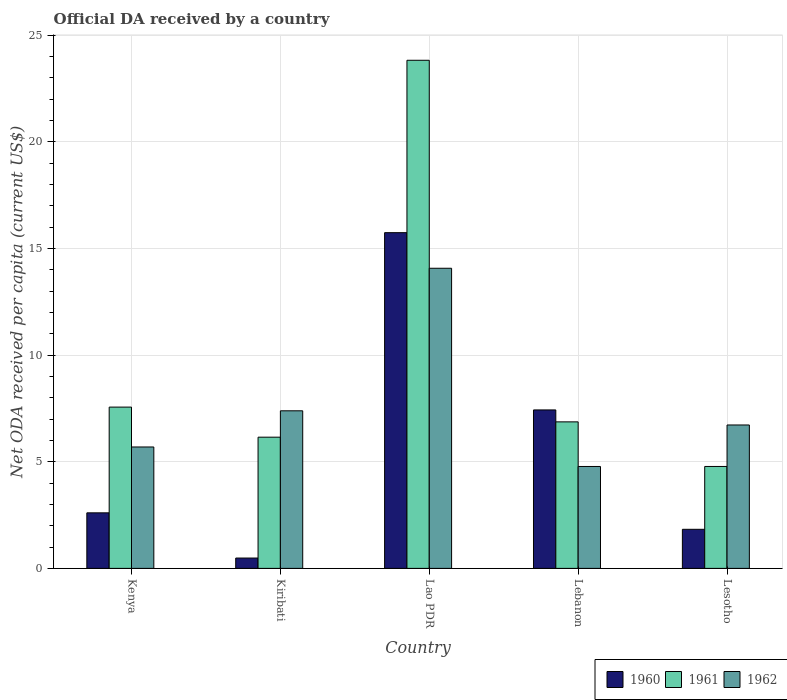How many different coloured bars are there?
Ensure brevity in your answer.  3. How many groups of bars are there?
Give a very brief answer. 5. Are the number of bars per tick equal to the number of legend labels?
Make the answer very short. Yes. Are the number of bars on each tick of the X-axis equal?
Your answer should be very brief. Yes. How many bars are there on the 5th tick from the left?
Offer a very short reply. 3. What is the label of the 1st group of bars from the left?
Offer a terse response. Kenya. In how many cases, is the number of bars for a given country not equal to the number of legend labels?
Offer a very short reply. 0. What is the ODA received in in 1962 in Lebanon?
Provide a short and direct response. 4.78. Across all countries, what is the maximum ODA received in in 1960?
Your answer should be very brief. 15.74. Across all countries, what is the minimum ODA received in in 1961?
Your answer should be very brief. 4.78. In which country was the ODA received in in 1961 maximum?
Keep it short and to the point. Lao PDR. In which country was the ODA received in in 1961 minimum?
Provide a short and direct response. Lesotho. What is the total ODA received in in 1961 in the graph?
Offer a very short reply. 49.19. What is the difference between the ODA received in in 1960 in Lao PDR and that in Lesotho?
Provide a short and direct response. 13.91. What is the difference between the ODA received in in 1961 in Lao PDR and the ODA received in in 1962 in Lesotho?
Your response must be concise. 17.1. What is the average ODA received in in 1962 per country?
Provide a short and direct response. 7.73. What is the difference between the ODA received in of/in 1960 and ODA received in of/in 1962 in Kiribati?
Offer a very short reply. -6.9. In how many countries, is the ODA received in in 1960 greater than 18 US$?
Offer a terse response. 0. What is the ratio of the ODA received in in 1961 in Lao PDR to that in Lesotho?
Keep it short and to the point. 4.98. Is the ODA received in in 1960 in Kiribati less than that in Lao PDR?
Provide a succinct answer. Yes. Is the difference between the ODA received in in 1960 in Kenya and Lao PDR greater than the difference between the ODA received in in 1962 in Kenya and Lao PDR?
Provide a short and direct response. No. What is the difference between the highest and the second highest ODA received in in 1960?
Give a very brief answer. -4.83. What is the difference between the highest and the lowest ODA received in in 1960?
Offer a very short reply. 15.26. In how many countries, is the ODA received in in 1960 greater than the average ODA received in in 1960 taken over all countries?
Provide a succinct answer. 2. What does the 2nd bar from the right in Lao PDR represents?
Your response must be concise. 1961. Is it the case that in every country, the sum of the ODA received in in 1961 and ODA received in in 1960 is greater than the ODA received in in 1962?
Provide a succinct answer. No. Are all the bars in the graph horizontal?
Offer a very short reply. No. How many countries are there in the graph?
Provide a short and direct response. 5. Are the values on the major ticks of Y-axis written in scientific E-notation?
Keep it short and to the point. No. Does the graph contain any zero values?
Ensure brevity in your answer.  No. Where does the legend appear in the graph?
Provide a succinct answer. Bottom right. How are the legend labels stacked?
Provide a short and direct response. Horizontal. What is the title of the graph?
Keep it short and to the point. Official DA received by a country. What is the label or title of the X-axis?
Ensure brevity in your answer.  Country. What is the label or title of the Y-axis?
Ensure brevity in your answer.  Net ODA received per capita (current US$). What is the Net ODA received per capita (current US$) of 1960 in Kenya?
Provide a short and direct response. 2.6. What is the Net ODA received per capita (current US$) in 1961 in Kenya?
Keep it short and to the point. 7.56. What is the Net ODA received per capita (current US$) in 1962 in Kenya?
Provide a short and direct response. 5.69. What is the Net ODA received per capita (current US$) in 1960 in Kiribati?
Keep it short and to the point. 0.49. What is the Net ODA received per capita (current US$) in 1961 in Kiribati?
Offer a terse response. 6.15. What is the Net ODA received per capita (current US$) in 1962 in Kiribati?
Provide a short and direct response. 7.39. What is the Net ODA received per capita (current US$) of 1960 in Lao PDR?
Your answer should be compact. 15.74. What is the Net ODA received per capita (current US$) in 1961 in Lao PDR?
Your response must be concise. 23.82. What is the Net ODA received per capita (current US$) in 1962 in Lao PDR?
Your response must be concise. 14.07. What is the Net ODA received per capita (current US$) of 1960 in Lebanon?
Offer a terse response. 7.43. What is the Net ODA received per capita (current US$) in 1961 in Lebanon?
Keep it short and to the point. 6.87. What is the Net ODA received per capita (current US$) in 1962 in Lebanon?
Offer a very short reply. 4.78. What is the Net ODA received per capita (current US$) in 1960 in Lesotho?
Provide a succinct answer. 1.83. What is the Net ODA received per capita (current US$) in 1961 in Lesotho?
Offer a terse response. 4.78. What is the Net ODA received per capita (current US$) of 1962 in Lesotho?
Provide a short and direct response. 6.72. Across all countries, what is the maximum Net ODA received per capita (current US$) in 1960?
Provide a succinct answer. 15.74. Across all countries, what is the maximum Net ODA received per capita (current US$) in 1961?
Your answer should be compact. 23.82. Across all countries, what is the maximum Net ODA received per capita (current US$) of 1962?
Your answer should be compact. 14.07. Across all countries, what is the minimum Net ODA received per capita (current US$) in 1960?
Give a very brief answer. 0.49. Across all countries, what is the minimum Net ODA received per capita (current US$) in 1961?
Keep it short and to the point. 4.78. Across all countries, what is the minimum Net ODA received per capita (current US$) of 1962?
Your answer should be compact. 4.78. What is the total Net ODA received per capita (current US$) in 1960 in the graph?
Offer a very short reply. 28.09. What is the total Net ODA received per capita (current US$) of 1961 in the graph?
Provide a short and direct response. 49.19. What is the total Net ODA received per capita (current US$) in 1962 in the graph?
Provide a succinct answer. 38.66. What is the difference between the Net ODA received per capita (current US$) of 1960 in Kenya and that in Kiribati?
Provide a short and direct response. 2.12. What is the difference between the Net ODA received per capita (current US$) of 1961 in Kenya and that in Kiribati?
Provide a succinct answer. 1.41. What is the difference between the Net ODA received per capita (current US$) in 1962 in Kenya and that in Kiribati?
Ensure brevity in your answer.  -1.7. What is the difference between the Net ODA received per capita (current US$) of 1960 in Kenya and that in Lao PDR?
Offer a terse response. -13.14. What is the difference between the Net ODA received per capita (current US$) in 1961 in Kenya and that in Lao PDR?
Your answer should be compact. -16.26. What is the difference between the Net ODA received per capita (current US$) of 1962 in Kenya and that in Lao PDR?
Keep it short and to the point. -8.38. What is the difference between the Net ODA received per capita (current US$) in 1960 in Kenya and that in Lebanon?
Your answer should be compact. -4.83. What is the difference between the Net ODA received per capita (current US$) of 1961 in Kenya and that in Lebanon?
Your response must be concise. 0.69. What is the difference between the Net ODA received per capita (current US$) of 1962 in Kenya and that in Lebanon?
Make the answer very short. 0.91. What is the difference between the Net ODA received per capita (current US$) in 1960 in Kenya and that in Lesotho?
Ensure brevity in your answer.  0.77. What is the difference between the Net ODA received per capita (current US$) of 1961 in Kenya and that in Lesotho?
Ensure brevity in your answer.  2.78. What is the difference between the Net ODA received per capita (current US$) in 1962 in Kenya and that in Lesotho?
Give a very brief answer. -1.03. What is the difference between the Net ODA received per capita (current US$) in 1960 in Kiribati and that in Lao PDR?
Offer a very short reply. -15.26. What is the difference between the Net ODA received per capita (current US$) in 1961 in Kiribati and that in Lao PDR?
Your answer should be very brief. -17.67. What is the difference between the Net ODA received per capita (current US$) of 1962 in Kiribati and that in Lao PDR?
Provide a succinct answer. -6.68. What is the difference between the Net ODA received per capita (current US$) of 1960 in Kiribati and that in Lebanon?
Provide a succinct answer. -6.94. What is the difference between the Net ODA received per capita (current US$) in 1961 in Kiribati and that in Lebanon?
Give a very brief answer. -0.72. What is the difference between the Net ODA received per capita (current US$) of 1962 in Kiribati and that in Lebanon?
Give a very brief answer. 2.61. What is the difference between the Net ODA received per capita (current US$) of 1960 in Kiribati and that in Lesotho?
Ensure brevity in your answer.  -1.35. What is the difference between the Net ODA received per capita (current US$) in 1961 in Kiribati and that in Lesotho?
Your response must be concise. 1.37. What is the difference between the Net ODA received per capita (current US$) in 1962 in Kiribati and that in Lesotho?
Your response must be concise. 0.66. What is the difference between the Net ODA received per capita (current US$) of 1960 in Lao PDR and that in Lebanon?
Your response must be concise. 8.31. What is the difference between the Net ODA received per capita (current US$) of 1961 in Lao PDR and that in Lebanon?
Your response must be concise. 16.95. What is the difference between the Net ODA received per capita (current US$) in 1962 in Lao PDR and that in Lebanon?
Your response must be concise. 9.29. What is the difference between the Net ODA received per capita (current US$) of 1960 in Lao PDR and that in Lesotho?
Offer a terse response. 13.91. What is the difference between the Net ODA received per capita (current US$) of 1961 in Lao PDR and that in Lesotho?
Provide a succinct answer. 19.04. What is the difference between the Net ODA received per capita (current US$) in 1962 in Lao PDR and that in Lesotho?
Offer a very short reply. 7.35. What is the difference between the Net ODA received per capita (current US$) of 1960 in Lebanon and that in Lesotho?
Give a very brief answer. 5.6. What is the difference between the Net ODA received per capita (current US$) in 1961 in Lebanon and that in Lesotho?
Provide a succinct answer. 2.09. What is the difference between the Net ODA received per capita (current US$) of 1962 in Lebanon and that in Lesotho?
Offer a terse response. -1.95. What is the difference between the Net ODA received per capita (current US$) of 1960 in Kenya and the Net ODA received per capita (current US$) of 1961 in Kiribati?
Give a very brief answer. -3.55. What is the difference between the Net ODA received per capita (current US$) of 1960 in Kenya and the Net ODA received per capita (current US$) of 1962 in Kiribati?
Provide a short and direct response. -4.78. What is the difference between the Net ODA received per capita (current US$) of 1961 in Kenya and the Net ODA received per capita (current US$) of 1962 in Kiribati?
Offer a very short reply. 0.17. What is the difference between the Net ODA received per capita (current US$) of 1960 in Kenya and the Net ODA received per capita (current US$) of 1961 in Lao PDR?
Ensure brevity in your answer.  -21.22. What is the difference between the Net ODA received per capita (current US$) of 1960 in Kenya and the Net ODA received per capita (current US$) of 1962 in Lao PDR?
Offer a very short reply. -11.47. What is the difference between the Net ODA received per capita (current US$) of 1961 in Kenya and the Net ODA received per capita (current US$) of 1962 in Lao PDR?
Give a very brief answer. -6.51. What is the difference between the Net ODA received per capita (current US$) in 1960 in Kenya and the Net ODA received per capita (current US$) in 1961 in Lebanon?
Keep it short and to the point. -4.27. What is the difference between the Net ODA received per capita (current US$) in 1960 in Kenya and the Net ODA received per capita (current US$) in 1962 in Lebanon?
Give a very brief answer. -2.17. What is the difference between the Net ODA received per capita (current US$) in 1961 in Kenya and the Net ODA received per capita (current US$) in 1962 in Lebanon?
Provide a succinct answer. 2.78. What is the difference between the Net ODA received per capita (current US$) in 1960 in Kenya and the Net ODA received per capita (current US$) in 1961 in Lesotho?
Your answer should be compact. -2.17. What is the difference between the Net ODA received per capita (current US$) of 1960 in Kenya and the Net ODA received per capita (current US$) of 1962 in Lesotho?
Ensure brevity in your answer.  -4.12. What is the difference between the Net ODA received per capita (current US$) of 1961 in Kenya and the Net ODA received per capita (current US$) of 1962 in Lesotho?
Offer a very short reply. 0.84. What is the difference between the Net ODA received per capita (current US$) in 1960 in Kiribati and the Net ODA received per capita (current US$) in 1961 in Lao PDR?
Your answer should be very brief. -23.34. What is the difference between the Net ODA received per capita (current US$) of 1960 in Kiribati and the Net ODA received per capita (current US$) of 1962 in Lao PDR?
Keep it short and to the point. -13.59. What is the difference between the Net ODA received per capita (current US$) of 1961 in Kiribati and the Net ODA received per capita (current US$) of 1962 in Lao PDR?
Offer a very short reply. -7.92. What is the difference between the Net ODA received per capita (current US$) in 1960 in Kiribati and the Net ODA received per capita (current US$) in 1961 in Lebanon?
Keep it short and to the point. -6.39. What is the difference between the Net ODA received per capita (current US$) of 1960 in Kiribati and the Net ODA received per capita (current US$) of 1962 in Lebanon?
Provide a short and direct response. -4.29. What is the difference between the Net ODA received per capita (current US$) in 1961 in Kiribati and the Net ODA received per capita (current US$) in 1962 in Lebanon?
Provide a short and direct response. 1.37. What is the difference between the Net ODA received per capita (current US$) of 1960 in Kiribati and the Net ODA received per capita (current US$) of 1961 in Lesotho?
Your answer should be very brief. -4.29. What is the difference between the Net ODA received per capita (current US$) in 1960 in Kiribati and the Net ODA received per capita (current US$) in 1962 in Lesotho?
Your answer should be compact. -6.24. What is the difference between the Net ODA received per capita (current US$) in 1961 in Kiribati and the Net ODA received per capita (current US$) in 1962 in Lesotho?
Provide a succinct answer. -0.57. What is the difference between the Net ODA received per capita (current US$) of 1960 in Lao PDR and the Net ODA received per capita (current US$) of 1961 in Lebanon?
Provide a short and direct response. 8.87. What is the difference between the Net ODA received per capita (current US$) in 1960 in Lao PDR and the Net ODA received per capita (current US$) in 1962 in Lebanon?
Ensure brevity in your answer.  10.96. What is the difference between the Net ODA received per capita (current US$) in 1961 in Lao PDR and the Net ODA received per capita (current US$) in 1962 in Lebanon?
Your answer should be compact. 19.05. What is the difference between the Net ODA received per capita (current US$) of 1960 in Lao PDR and the Net ODA received per capita (current US$) of 1961 in Lesotho?
Give a very brief answer. 10.96. What is the difference between the Net ODA received per capita (current US$) of 1960 in Lao PDR and the Net ODA received per capita (current US$) of 1962 in Lesotho?
Give a very brief answer. 9.02. What is the difference between the Net ODA received per capita (current US$) of 1961 in Lao PDR and the Net ODA received per capita (current US$) of 1962 in Lesotho?
Your answer should be compact. 17.1. What is the difference between the Net ODA received per capita (current US$) in 1960 in Lebanon and the Net ODA received per capita (current US$) in 1961 in Lesotho?
Ensure brevity in your answer.  2.65. What is the difference between the Net ODA received per capita (current US$) of 1960 in Lebanon and the Net ODA received per capita (current US$) of 1962 in Lesotho?
Make the answer very short. 0.71. What is the difference between the Net ODA received per capita (current US$) of 1961 in Lebanon and the Net ODA received per capita (current US$) of 1962 in Lesotho?
Provide a short and direct response. 0.15. What is the average Net ODA received per capita (current US$) in 1960 per country?
Give a very brief answer. 5.62. What is the average Net ODA received per capita (current US$) in 1961 per country?
Offer a terse response. 9.84. What is the average Net ODA received per capita (current US$) in 1962 per country?
Offer a terse response. 7.73. What is the difference between the Net ODA received per capita (current US$) in 1960 and Net ODA received per capita (current US$) in 1961 in Kenya?
Ensure brevity in your answer.  -4.96. What is the difference between the Net ODA received per capita (current US$) of 1960 and Net ODA received per capita (current US$) of 1962 in Kenya?
Make the answer very short. -3.09. What is the difference between the Net ODA received per capita (current US$) of 1961 and Net ODA received per capita (current US$) of 1962 in Kenya?
Make the answer very short. 1.87. What is the difference between the Net ODA received per capita (current US$) of 1960 and Net ODA received per capita (current US$) of 1961 in Kiribati?
Provide a short and direct response. -5.67. What is the difference between the Net ODA received per capita (current US$) of 1960 and Net ODA received per capita (current US$) of 1962 in Kiribati?
Your response must be concise. -6.9. What is the difference between the Net ODA received per capita (current US$) in 1961 and Net ODA received per capita (current US$) in 1962 in Kiribati?
Provide a short and direct response. -1.24. What is the difference between the Net ODA received per capita (current US$) in 1960 and Net ODA received per capita (current US$) in 1961 in Lao PDR?
Give a very brief answer. -8.08. What is the difference between the Net ODA received per capita (current US$) of 1960 and Net ODA received per capita (current US$) of 1962 in Lao PDR?
Make the answer very short. 1.67. What is the difference between the Net ODA received per capita (current US$) in 1961 and Net ODA received per capita (current US$) in 1962 in Lao PDR?
Give a very brief answer. 9.75. What is the difference between the Net ODA received per capita (current US$) of 1960 and Net ODA received per capita (current US$) of 1961 in Lebanon?
Your answer should be compact. 0.56. What is the difference between the Net ODA received per capita (current US$) in 1960 and Net ODA received per capita (current US$) in 1962 in Lebanon?
Keep it short and to the point. 2.65. What is the difference between the Net ODA received per capita (current US$) of 1961 and Net ODA received per capita (current US$) of 1962 in Lebanon?
Make the answer very short. 2.09. What is the difference between the Net ODA received per capita (current US$) in 1960 and Net ODA received per capita (current US$) in 1961 in Lesotho?
Offer a terse response. -2.95. What is the difference between the Net ODA received per capita (current US$) in 1960 and Net ODA received per capita (current US$) in 1962 in Lesotho?
Offer a terse response. -4.89. What is the difference between the Net ODA received per capita (current US$) of 1961 and Net ODA received per capita (current US$) of 1962 in Lesotho?
Provide a succinct answer. -1.94. What is the ratio of the Net ODA received per capita (current US$) of 1960 in Kenya to that in Kiribati?
Make the answer very short. 5.37. What is the ratio of the Net ODA received per capita (current US$) of 1961 in Kenya to that in Kiribati?
Give a very brief answer. 1.23. What is the ratio of the Net ODA received per capita (current US$) in 1962 in Kenya to that in Kiribati?
Make the answer very short. 0.77. What is the ratio of the Net ODA received per capita (current US$) in 1960 in Kenya to that in Lao PDR?
Your answer should be very brief. 0.17. What is the ratio of the Net ODA received per capita (current US$) in 1961 in Kenya to that in Lao PDR?
Make the answer very short. 0.32. What is the ratio of the Net ODA received per capita (current US$) in 1962 in Kenya to that in Lao PDR?
Offer a very short reply. 0.4. What is the ratio of the Net ODA received per capita (current US$) of 1960 in Kenya to that in Lebanon?
Ensure brevity in your answer.  0.35. What is the ratio of the Net ODA received per capita (current US$) of 1961 in Kenya to that in Lebanon?
Offer a very short reply. 1.1. What is the ratio of the Net ODA received per capita (current US$) of 1962 in Kenya to that in Lebanon?
Your response must be concise. 1.19. What is the ratio of the Net ODA received per capita (current US$) in 1960 in Kenya to that in Lesotho?
Make the answer very short. 1.42. What is the ratio of the Net ODA received per capita (current US$) of 1961 in Kenya to that in Lesotho?
Your response must be concise. 1.58. What is the ratio of the Net ODA received per capita (current US$) of 1962 in Kenya to that in Lesotho?
Offer a terse response. 0.85. What is the ratio of the Net ODA received per capita (current US$) in 1960 in Kiribati to that in Lao PDR?
Offer a terse response. 0.03. What is the ratio of the Net ODA received per capita (current US$) of 1961 in Kiribati to that in Lao PDR?
Your response must be concise. 0.26. What is the ratio of the Net ODA received per capita (current US$) in 1962 in Kiribati to that in Lao PDR?
Offer a terse response. 0.53. What is the ratio of the Net ODA received per capita (current US$) in 1960 in Kiribati to that in Lebanon?
Your answer should be compact. 0.07. What is the ratio of the Net ODA received per capita (current US$) in 1961 in Kiribati to that in Lebanon?
Offer a terse response. 0.9. What is the ratio of the Net ODA received per capita (current US$) in 1962 in Kiribati to that in Lebanon?
Offer a terse response. 1.55. What is the ratio of the Net ODA received per capita (current US$) of 1960 in Kiribati to that in Lesotho?
Your answer should be compact. 0.26. What is the ratio of the Net ODA received per capita (current US$) in 1961 in Kiribati to that in Lesotho?
Offer a terse response. 1.29. What is the ratio of the Net ODA received per capita (current US$) in 1962 in Kiribati to that in Lesotho?
Your response must be concise. 1.1. What is the ratio of the Net ODA received per capita (current US$) of 1960 in Lao PDR to that in Lebanon?
Keep it short and to the point. 2.12. What is the ratio of the Net ODA received per capita (current US$) of 1961 in Lao PDR to that in Lebanon?
Offer a very short reply. 3.47. What is the ratio of the Net ODA received per capita (current US$) in 1962 in Lao PDR to that in Lebanon?
Keep it short and to the point. 2.94. What is the ratio of the Net ODA received per capita (current US$) of 1960 in Lao PDR to that in Lesotho?
Give a very brief answer. 8.59. What is the ratio of the Net ODA received per capita (current US$) in 1961 in Lao PDR to that in Lesotho?
Ensure brevity in your answer.  4.98. What is the ratio of the Net ODA received per capita (current US$) of 1962 in Lao PDR to that in Lesotho?
Provide a succinct answer. 2.09. What is the ratio of the Net ODA received per capita (current US$) of 1960 in Lebanon to that in Lesotho?
Your response must be concise. 4.05. What is the ratio of the Net ODA received per capita (current US$) in 1961 in Lebanon to that in Lesotho?
Give a very brief answer. 1.44. What is the ratio of the Net ODA received per capita (current US$) of 1962 in Lebanon to that in Lesotho?
Your response must be concise. 0.71. What is the difference between the highest and the second highest Net ODA received per capita (current US$) of 1960?
Keep it short and to the point. 8.31. What is the difference between the highest and the second highest Net ODA received per capita (current US$) in 1961?
Ensure brevity in your answer.  16.26. What is the difference between the highest and the second highest Net ODA received per capita (current US$) of 1962?
Ensure brevity in your answer.  6.68. What is the difference between the highest and the lowest Net ODA received per capita (current US$) in 1960?
Provide a succinct answer. 15.26. What is the difference between the highest and the lowest Net ODA received per capita (current US$) in 1961?
Your response must be concise. 19.04. What is the difference between the highest and the lowest Net ODA received per capita (current US$) of 1962?
Your answer should be very brief. 9.29. 